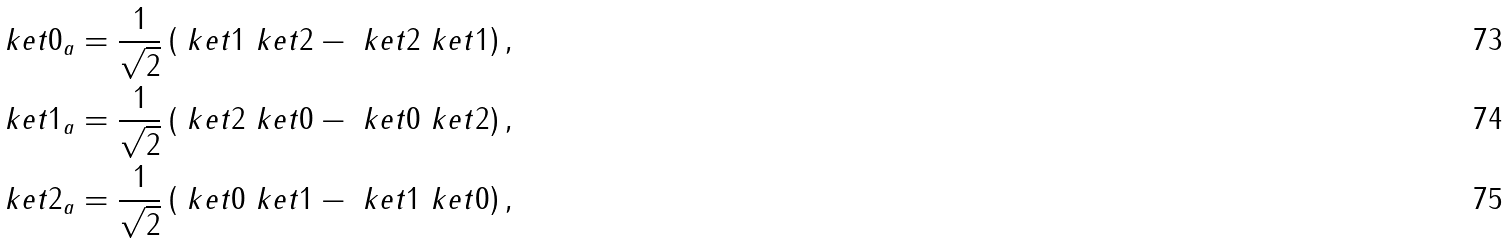Convert formula to latex. <formula><loc_0><loc_0><loc_500><loc_500>\ k e t { 0 } _ { a } & = \frac { 1 } { \sqrt { 2 } } \left ( \ k e t { 1 } \ k e t { 2 } - \ k e t { 2 } \ k e t { 1 } \right ) , \\ \ k e t { 1 } _ { a } & = \frac { 1 } { \sqrt { 2 } } \left ( \ k e t { 2 } \ k e t { 0 } - \ k e t { 0 } \ k e t { 2 } \right ) , \\ \ k e t { 2 } _ { a } & = \frac { 1 } { \sqrt { 2 } } \left ( \ k e t { 0 } \ k e t { 1 } - \ k e t { 1 } \ k e t { 0 } \right ) ,</formula> 